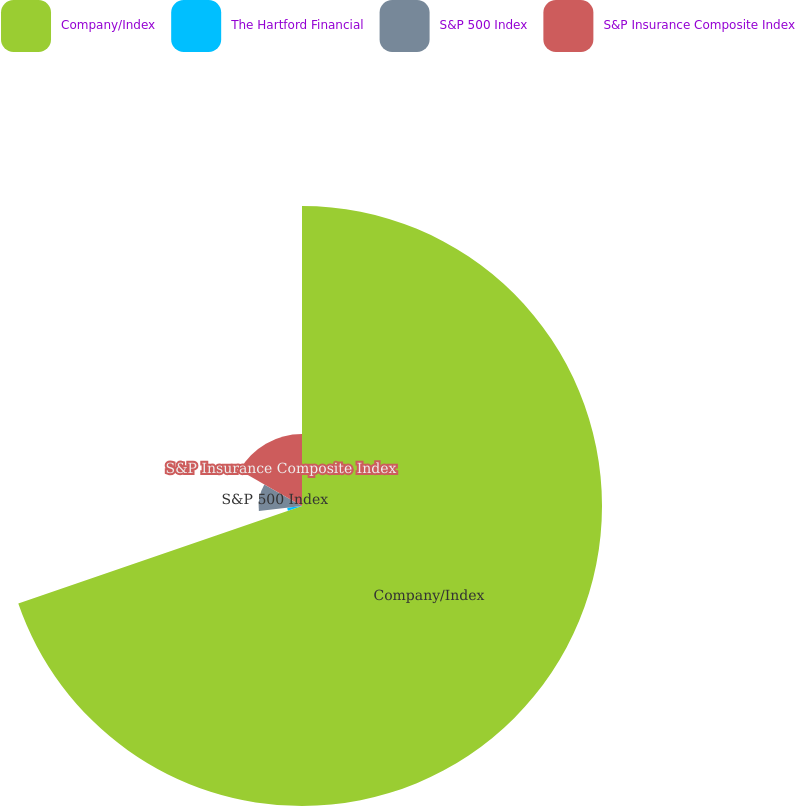Convert chart to OTSL. <chart><loc_0><loc_0><loc_500><loc_500><pie_chart><fcel>Company/Index<fcel>The Hartford Financial<fcel>S&P 500 Index<fcel>S&P Insurance Composite Index<nl><fcel>69.73%<fcel>3.46%<fcel>10.09%<fcel>16.72%<nl></chart> 